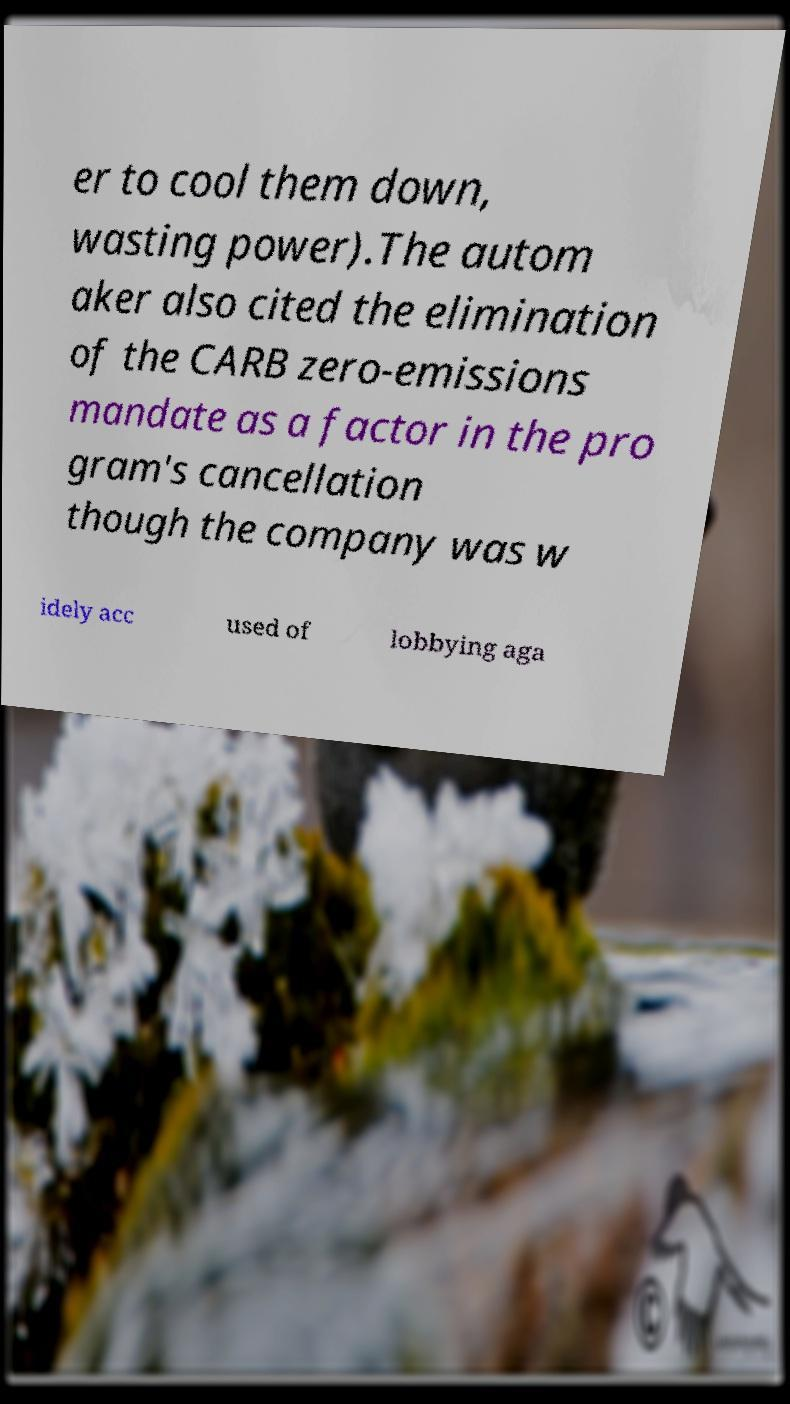Can you read and provide the text displayed in the image?This photo seems to have some interesting text. Can you extract and type it out for me? er to cool them down, wasting power).The autom aker also cited the elimination of the CARB zero-emissions mandate as a factor in the pro gram's cancellation though the company was w idely acc used of lobbying aga 